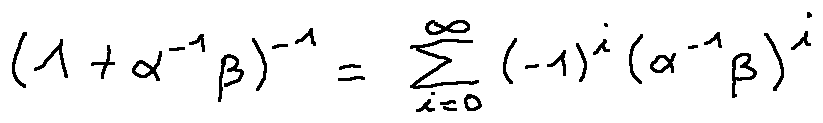Convert formula to latex. <formula><loc_0><loc_0><loc_500><loc_500>( 1 + \alpha ^ { - 1 } \beta ) ^ { - 1 } = \sum \lim i t s _ { i = 0 } ^ { \infty } ( - 1 ) ^ { i } ( \alpha ^ { - 1 } \beta ) ^ { i }</formula> 